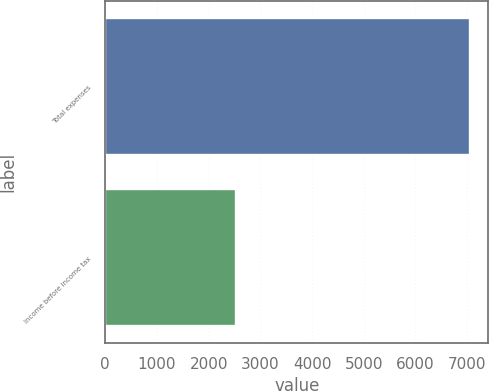Convert chart. <chart><loc_0><loc_0><loc_500><loc_500><bar_chart><fcel>Total expenses<fcel>Income before income tax<nl><fcel>7058<fcel>2536<nl></chart> 